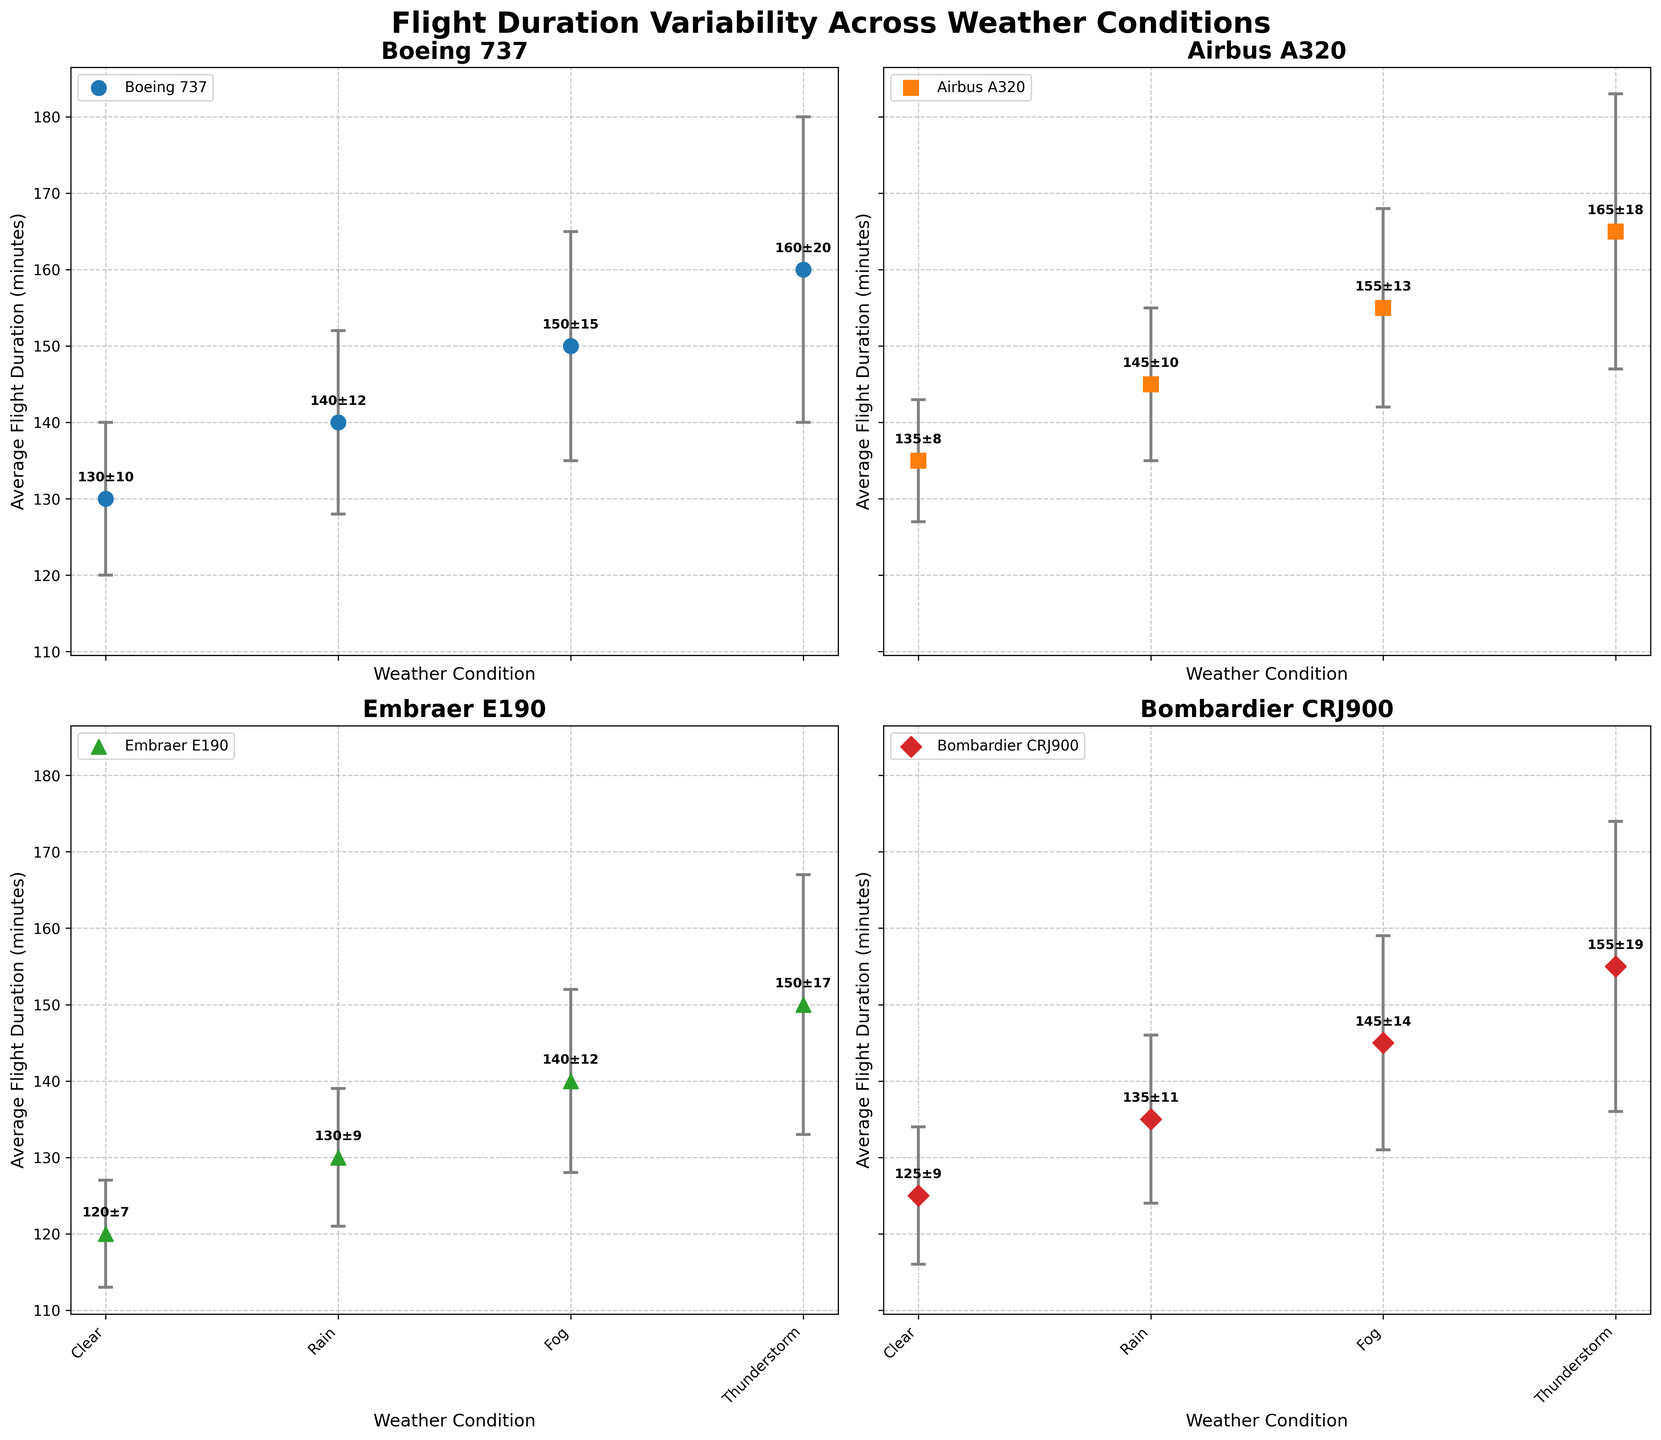what is the title of the figure? The title of the figure is shown at the top and reads 'Flight Duration Variability Across Weather Conditions'.
Answer: Flight Duration Variability Across Weather Conditions How many different aircraft models are compared in the plots? There are four sets of subplots, indicating that there are four different aircraft models compared.
Answer: Four What's the average flight duration for the Airbus A320 in clear weather? In the subplot for Airbus A320, the average flight duration for clear weather (the first data point) is annotated near the first marker; it reads 135 ± 8 minutes.
Answer: 135 minutes Which aircraft model experiences the highest variability in flight duration during thunderstorms? The aircraft model with the highest variability in flight duration during thunderstorms is indicated by the largest error bar in the 'Thunderstorm' category. For Boeing 737, it's ±20 minutes.
Answer: Boeing 737 What's the difference in average flight duration for the Boeing 737 between clear and rainy weather conditions? The average flight duration for clear weather is 130 minutes, and for rain, it is 140 minutes. The difference is 140 - 130 = 10 minutes.
Answer: 10 minutes Which weather condition generally shows the largest standard deviation in flight durations across all models? By comparing the size of error bars across all subplots, thunderstorms generally show the largest standard deviation in flight durations.
Answer: Thunderstorm What is the rank of Embraer E190 among the listed aircraft models in terms of average flight duration in foggy weather? Comparing the values in the 'Fog' weather condition in each subplot, Embraer E190 is third (140 minutes) after Airbus A320 (155 minutes) and Boeing 737 (150 minutes).
Answer: Third Are there any weather conditions where Bombardier CRJ900 has a shorter average flight duration than Boeing 737? In clear (125) and rainy (135) conditions, Bombardier CRJ900 has a shorter average flight duration compared to Boeing 737 (130 and 140 respectively).
Answer: Yes What's the relative reduction in average flight duration for Embraer E190 from thunderstorms to clear weather? For Embraer E190, clear weather average duration is 120 minutes, and for thunderstorms, it is 150 minutes. The relative reduction is (150 - 120) / 150 = 0.2 or 20%.
Answer: 20% Which aircraft model shows the greatest increase in flight duration when moving from clear to thunderstorm conditions? By calculating the increase for each model, Boeing 737 increases from 130 minutes (clear) to 160 minutes (thunderstorm), which is a 30-minute increase, the greatest among the models.
Answer: Boeing 737 